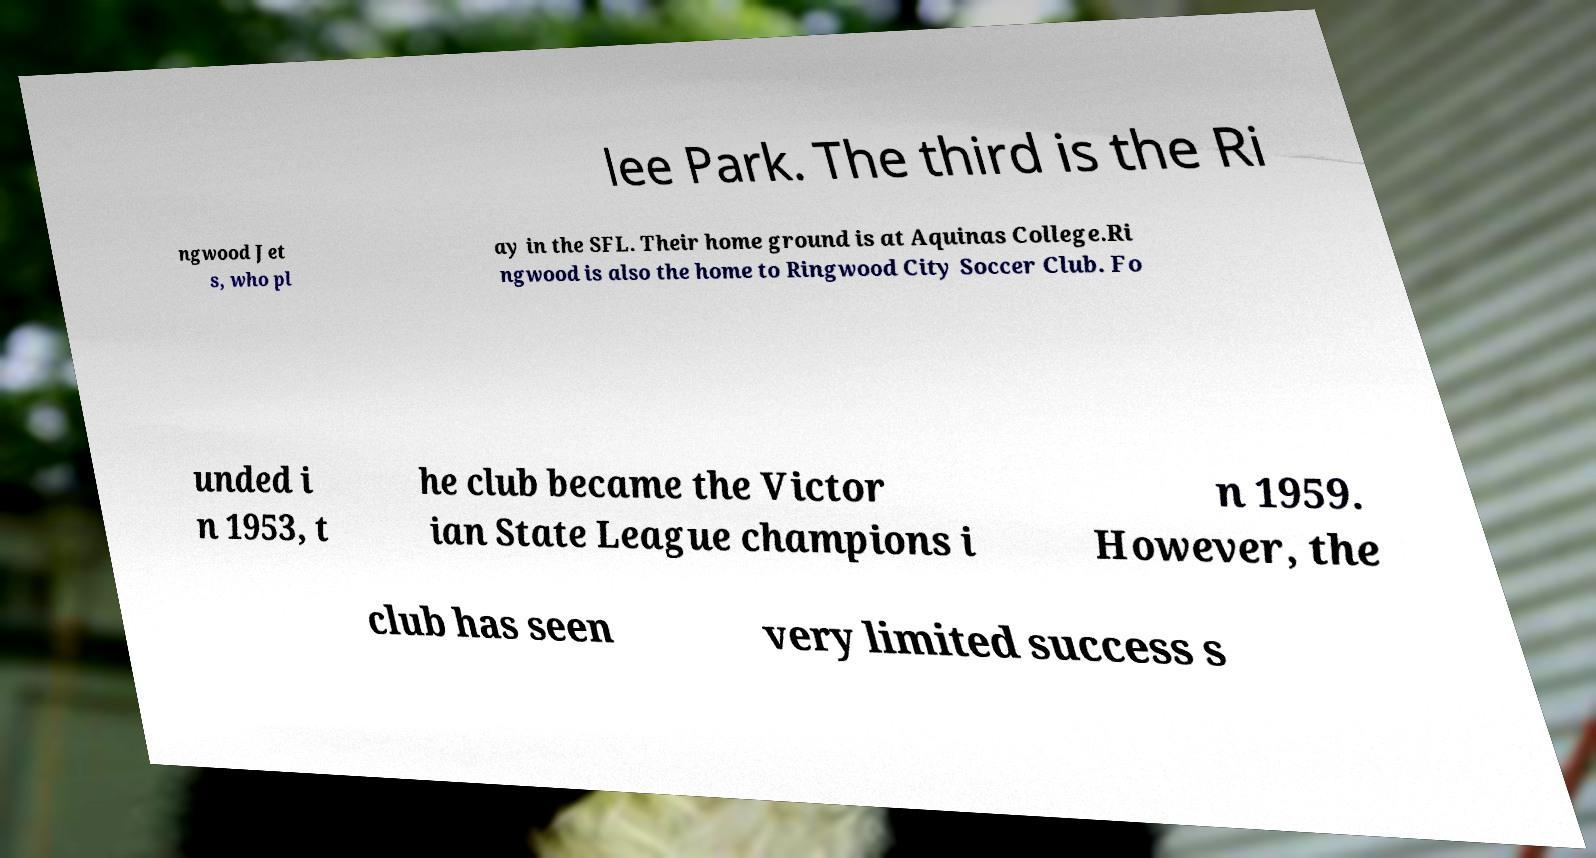I need the written content from this picture converted into text. Can you do that? lee Park. The third is the Ri ngwood Jet s, who pl ay in the SFL. Their home ground is at Aquinas College.Ri ngwood is also the home to Ringwood City Soccer Club. Fo unded i n 1953, t he club became the Victor ian State League champions i n 1959. However, the club has seen very limited success s 